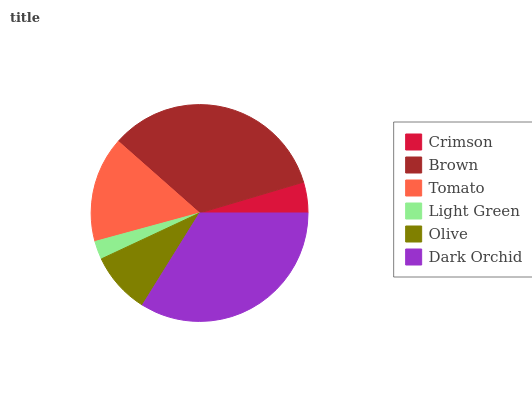Is Light Green the minimum?
Answer yes or no. Yes. Is Brown the maximum?
Answer yes or no. Yes. Is Tomato the minimum?
Answer yes or no. No. Is Tomato the maximum?
Answer yes or no. No. Is Brown greater than Tomato?
Answer yes or no. Yes. Is Tomato less than Brown?
Answer yes or no. Yes. Is Tomato greater than Brown?
Answer yes or no. No. Is Brown less than Tomato?
Answer yes or no. No. Is Tomato the high median?
Answer yes or no. Yes. Is Olive the low median?
Answer yes or no. Yes. Is Olive the high median?
Answer yes or no. No. Is Tomato the low median?
Answer yes or no. No. 